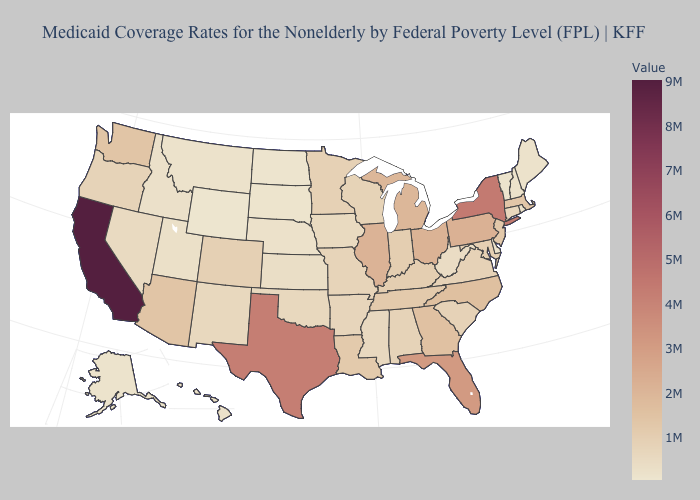Does New Mexico have a lower value than Texas?
Quick response, please. Yes. 